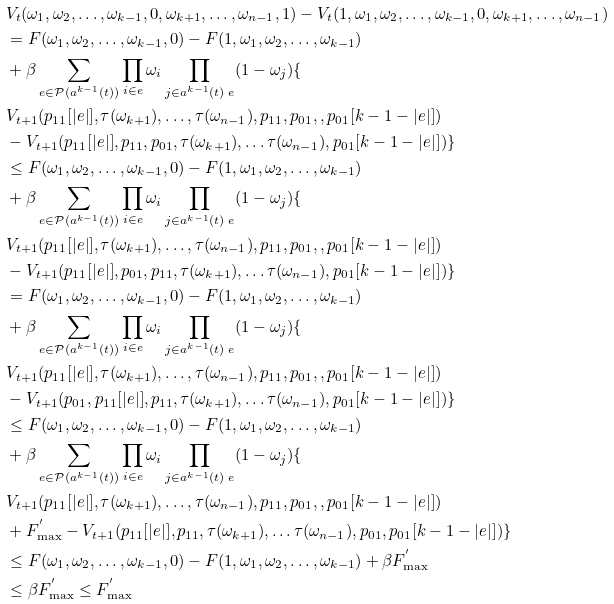<formula> <loc_0><loc_0><loc_500><loc_500>& V _ { t } ( \omega _ { 1 } , \omega _ { 2 } , \dots , \omega _ { k - 1 } , 0 , \omega _ { k + 1 } , \dots , \omega _ { n - 1 } , 1 ) - V _ { t } ( 1 , \omega _ { 1 } , \omega _ { 2 } , \dots , \omega _ { k - 1 } , 0 , \omega _ { k + 1 } , \dots , \omega _ { n - 1 } ) \\ & = F ( \omega _ { 1 } , \omega _ { 2 } , \dots , \omega _ { k - 1 } , 0 ) - F ( 1 , \omega _ { 1 } , \omega _ { 2 } , \dots , \omega _ { k - 1 } ) \\ & + \beta \sum _ { e \in { \mathcal { P } ( a ^ { k - 1 } ( t ) ) } } \prod _ { i \in { e } } \omega _ { i } \prod _ { j \in { a ^ { k - 1 } ( t ) \ { e } } } ( 1 - \omega _ { j } ) \{ \\ & V _ { t + 1 } ( p _ { 1 1 } [ | e | ] , \tau ( { \omega _ { k + 1 } } ) , \dots , \tau ( { \omega _ { n - 1 } } ) , p _ { 1 1 } , p _ { 0 1 } , , p _ { 0 1 } [ k - 1 - | e | ] ) \\ & - V _ { t + 1 } ( p _ { 1 1 } [ | e | ] , p _ { 1 1 } , p _ { 0 1 } , \tau ( { \omega _ { k + 1 } } ) , \dots \tau ( { \omega _ { n - 1 } } ) , p _ { 0 1 } [ k - 1 - | e | ] ) \} \\ & \leq F ( \omega _ { 1 } , \omega _ { 2 } , \dots , \omega _ { k - 1 } , 0 ) - F ( 1 , \omega _ { 1 } , \omega _ { 2 } , \dots , \omega _ { k - 1 } ) \\ & + \beta \sum _ { e \in { \mathcal { P } ( a ^ { k - 1 } ( t ) ) } } \prod _ { i \in { e } } \omega _ { i } \prod _ { j \in { a ^ { k - 1 } ( t ) \ { e } } } ( 1 - \omega _ { j } ) \{ \\ & V _ { t + 1 } ( p _ { 1 1 } [ | e | ] , \tau ( { \omega _ { k + 1 } } ) , \dots , \tau ( { \omega _ { n - 1 } } ) , p _ { 1 1 } , p _ { 0 1 } , , p _ { 0 1 } [ k - 1 - | e | ] ) \\ & - V _ { t + 1 } ( p _ { 1 1 } [ | e | ] , p _ { 0 1 } , p _ { 1 1 } , \tau ( { \omega _ { k + 1 } } ) , \dots \tau ( { \omega _ { n - 1 } } ) , p _ { 0 1 } [ k - 1 - | e | ] ) \} \\ & = F ( \omega _ { 1 } , \omega _ { 2 } , \dots , \omega _ { k - 1 } , 0 ) - F ( 1 , \omega _ { 1 } , \omega _ { 2 } , \dots , \omega _ { k - 1 } ) \\ & + \beta \sum _ { e \in { \mathcal { P } ( a ^ { k - 1 } ( t ) ) } } \prod _ { i \in { e } } \omega _ { i } \prod _ { j \in { a ^ { k - 1 } ( t ) \ { e } } } ( 1 - \omega _ { j } ) \{ \\ & V _ { t + 1 } ( p _ { 1 1 } [ | e | ] , \tau ( { \omega _ { k + 1 } } ) , \dots , \tau ( { \omega _ { n - 1 } } ) , p _ { 1 1 } , p _ { 0 1 } , , p _ { 0 1 } [ k - 1 - | e | ] ) \\ & - V _ { t + 1 } ( p _ { 0 1 } , p _ { 1 1 } [ | e | ] , p _ { 1 1 } , \tau ( { \omega _ { k + 1 } } ) , \dots \tau ( { \omega _ { n - 1 } } ) , p _ { 0 1 } [ k - 1 - | e | ] ) \} \\ & \leq F ( \omega _ { 1 } , \omega _ { 2 } , \dots , \omega _ { k - 1 } , 0 ) - F ( 1 , \omega _ { 1 } , \omega _ { 2 } , \dots , \omega _ { k - 1 } ) \\ & + \beta \sum _ { e \in { \mathcal { P } ( a ^ { k - 1 } ( t ) ) } } \prod _ { i \in { e } } \omega _ { i } \prod _ { j \in { a ^ { k - 1 } ( t ) \ { e } } } ( 1 - \omega _ { j } ) \{ \\ & V _ { t + 1 } ( p _ { 1 1 } [ | e | ] , \tau ( { \omega _ { k + 1 } } ) , \dots , \tau ( { \omega _ { n - 1 } } ) , p _ { 1 1 } , p _ { 0 1 } , , p _ { 0 1 } [ k - 1 - | e | ] ) \\ & + F _ { \max } ^ { ^ { \prime } } - V _ { t + 1 } ( p _ { 1 1 } [ | e | ] , p _ { 1 1 } , \tau ( { \omega _ { k + 1 } } ) , \dots \tau ( { \omega _ { n - 1 } } ) , p _ { 0 1 } , p _ { 0 1 } [ k - 1 - | e | ] ) \} \\ & \leq F ( \omega _ { 1 } , \omega _ { 2 } , \dots , \omega _ { k - 1 } , 0 ) - F ( 1 , \omega _ { 1 } , \omega _ { 2 } , \dots , \omega _ { k - 1 } ) + \beta F _ { \max } ^ { ^ { \prime } } \\ & \leq \beta F _ { \max } ^ { ^ { \prime } } \leq F _ { \max } ^ { ^ { \prime } }</formula> 